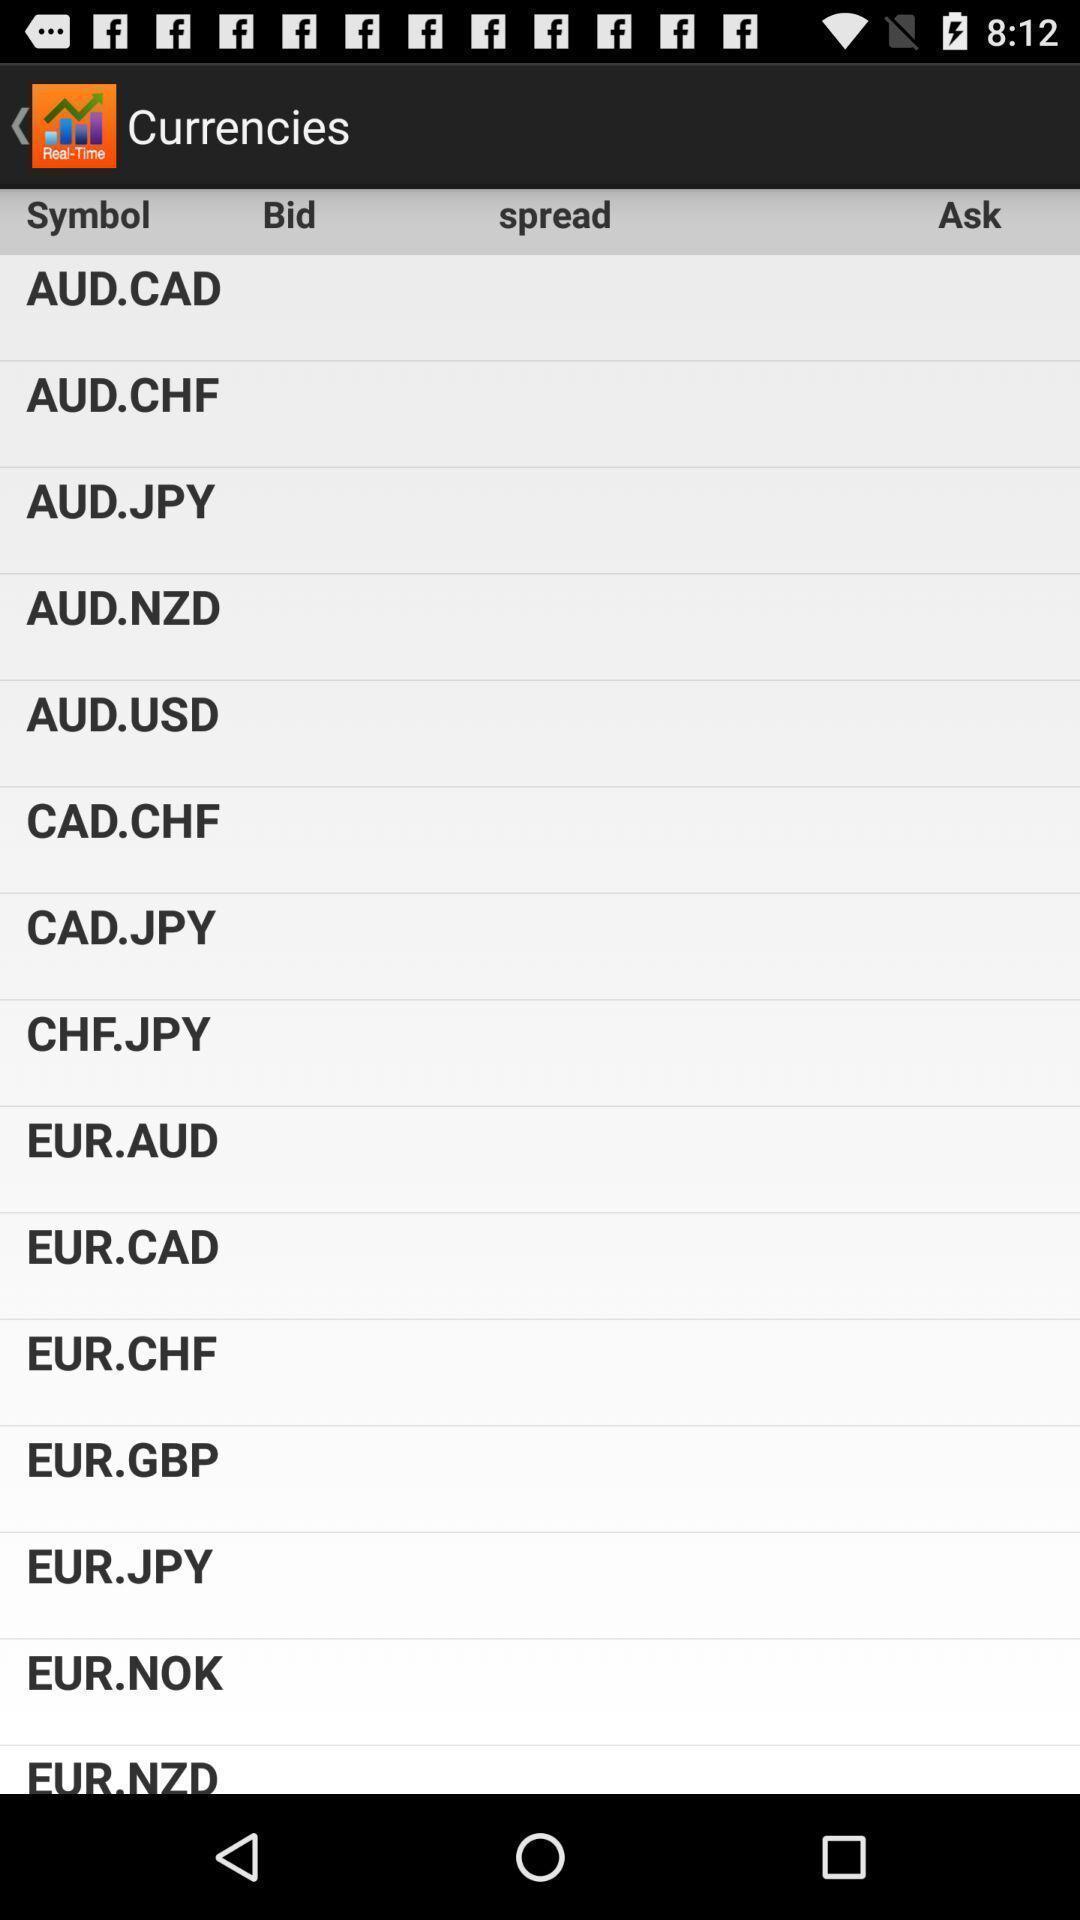What details can you identify in this image? Screen showing currencies. 